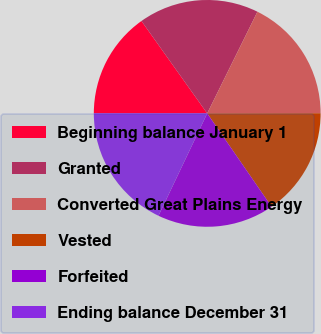Convert chart to OTSL. <chart><loc_0><loc_0><loc_500><loc_500><pie_chart><fcel>Beginning balance January 1<fcel>Granted<fcel>Converted Great Plains Energy<fcel>Vested<fcel>Forfeited<fcel>Ending balance December 31<nl><fcel>15.15%<fcel>17.15%<fcel>17.68%<fcel>15.41%<fcel>16.68%<fcel>17.94%<nl></chart> 